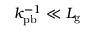<formula> <loc_0><loc_0><loc_500><loc_500>k _ { p b } ^ { - 1 } \ll L _ { g }</formula> 